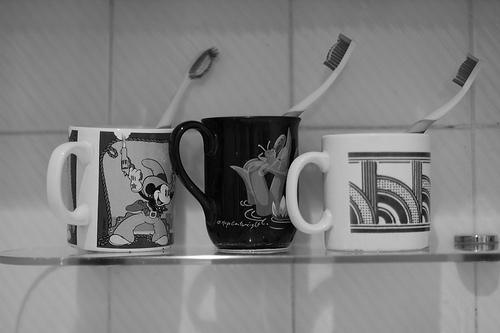How many toothbrushes are there?
Give a very brief answer. 3. 